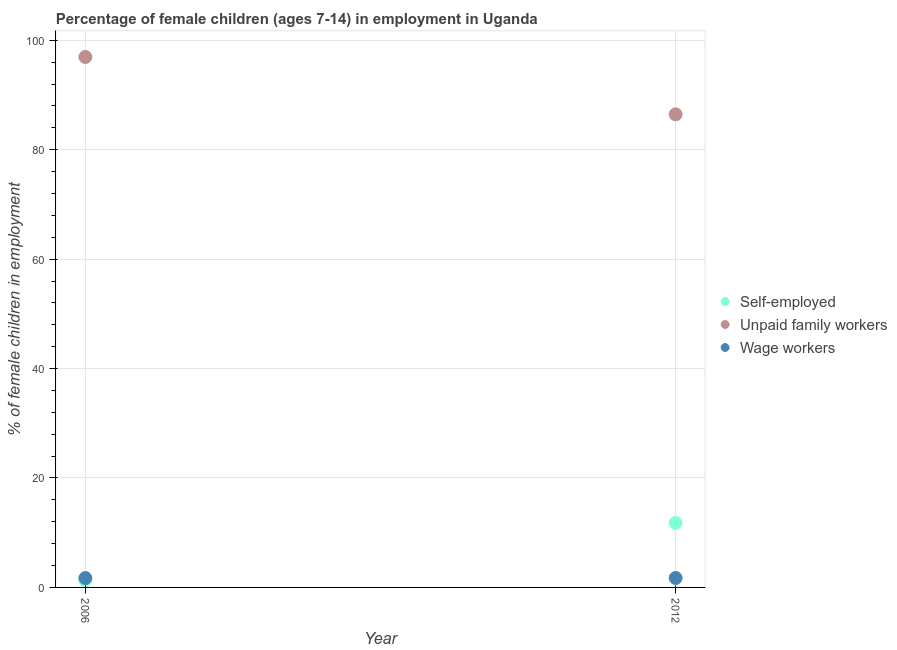What is the percentage of self employed children in 2006?
Give a very brief answer. 1.34. Across all years, what is the maximum percentage of children employed as unpaid family workers?
Offer a very short reply. 96.95. Across all years, what is the minimum percentage of children employed as unpaid family workers?
Provide a succinct answer. 86.47. In which year was the percentage of children employed as wage workers maximum?
Your answer should be very brief. 2012. What is the total percentage of children employed as unpaid family workers in the graph?
Make the answer very short. 183.42. What is the difference between the percentage of children employed as wage workers in 2006 and that in 2012?
Offer a terse response. -0.01. What is the difference between the percentage of self employed children in 2006 and the percentage of children employed as unpaid family workers in 2012?
Offer a terse response. -85.13. What is the average percentage of children employed as wage workers per year?
Ensure brevity in your answer.  1.71. In the year 2006, what is the difference between the percentage of children employed as unpaid family workers and percentage of self employed children?
Offer a terse response. 95.61. What is the ratio of the percentage of children employed as wage workers in 2006 to that in 2012?
Provide a succinct answer. 0.99. Is the percentage of self employed children in 2006 less than that in 2012?
Provide a succinct answer. Yes. Does the percentage of self employed children monotonically increase over the years?
Ensure brevity in your answer.  Yes. How many dotlines are there?
Ensure brevity in your answer.  3. How many years are there in the graph?
Your response must be concise. 2. What is the difference between two consecutive major ticks on the Y-axis?
Keep it short and to the point. 20. Does the graph contain grids?
Your response must be concise. Yes. Where does the legend appear in the graph?
Give a very brief answer. Center right. What is the title of the graph?
Make the answer very short. Percentage of female children (ages 7-14) in employment in Uganda. What is the label or title of the Y-axis?
Offer a terse response. % of female children in employment. What is the % of female children in employment in Self-employed in 2006?
Provide a short and direct response. 1.34. What is the % of female children in employment of Unpaid family workers in 2006?
Your response must be concise. 96.95. What is the % of female children in employment in Wage workers in 2006?
Give a very brief answer. 1.71. What is the % of female children in employment of Self-employed in 2012?
Provide a short and direct response. 11.79. What is the % of female children in employment of Unpaid family workers in 2012?
Your response must be concise. 86.47. What is the % of female children in employment in Wage workers in 2012?
Your response must be concise. 1.72. Across all years, what is the maximum % of female children in employment of Self-employed?
Make the answer very short. 11.79. Across all years, what is the maximum % of female children in employment in Unpaid family workers?
Offer a terse response. 96.95. Across all years, what is the maximum % of female children in employment of Wage workers?
Offer a terse response. 1.72. Across all years, what is the minimum % of female children in employment in Self-employed?
Provide a succinct answer. 1.34. Across all years, what is the minimum % of female children in employment in Unpaid family workers?
Give a very brief answer. 86.47. Across all years, what is the minimum % of female children in employment in Wage workers?
Offer a terse response. 1.71. What is the total % of female children in employment in Self-employed in the graph?
Offer a very short reply. 13.13. What is the total % of female children in employment in Unpaid family workers in the graph?
Make the answer very short. 183.42. What is the total % of female children in employment in Wage workers in the graph?
Make the answer very short. 3.43. What is the difference between the % of female children in employment of Self-employed in 2006 and that in 2012?
Offer a very short reply. -10.45. What is the difference between the % of female children in employment in Unpaid family workers in 2006 and that in 2012?
Ensure brevity in your answer.  10.48. What is the difference between the % of female children in employment in Wage workers in 2006 and that in 2012?
Provide a succinct answer. -0.01. What is the difference between the % of female children in employment of Self-employed in 2006 and the % of female children in employment of Unpaid family workers in 2012?
Make the answer very short. -85.13. What is the difference between the % of female children in employment in Self-employed in 2006 and the % of female children in employment in Wage workers in 2012?
Your answer should be very brief. -0.38. What is the difference between the % of female children in employment of Unpaid family workers in 2006 and the % of female children in employment of Wage workers in 2012?
Your response must be concise. 95.23. What is the average % of female children in employment of Self-employed per year?
Provide a short and direct response. 6.57. What is the average % of female children in employment of Unpaid family workers per year?
Your response must be concise. 91.71. What is the average % of female children in employment in Wage workers per year?
Your answer should be very brief. 1.72. In the year 2006, what is the difference between the % of female children in employment in Self-employed and % of female children in employment in Unpaid family workers?
Your answer should be very brief. -95.61. In the year 2006, what is the difference between the % of female children in employment of Self-employed and % of female children in employment of Wage workers?
Your answer should be compact. -0.37. In the year 2006, what is the difference between the % of female children in employment of Unpaid family workers and % of female children in employment of Wage workers?
Provide a succinct answer. 95.24. In the year 2012, what is the difference between the % of female children in employment in Self-employed and % of female children in employment in Unpaid family workers?
Make the answer very short. -74.68. In the year 2012, what is the difference between the % of female children in employment in Self-employed and % of female children in employment in Wage workers?
Provide a short and direct response. 10.07. In the year 2012, what is the difference between the % of female children in employment in Unpaid family workers and % of female children in employment in Wage workers?
Offer a very short reply. 84.75. What is the ratio of the % of female children in employment of Self-employed in 2006 to that in 2012?
Make the answer very short. 0.11. What is the ratio of the % of female children in employment of Unpaid family workers in 2006 to that in 2012?
Your response must be concise. 1.12. What is the difference between the highest and the second highest % of female children in employment in Self-employed?
Your response must be concise. 10.45. What is the difference between the highest and the second highest % of female children in employment in Unpaid family workers?
Your answer should be very brief. 10.48. What is the difference between the highest and the second highest % of female children in employment of Wage workers?
Your response must be concise. 0.01. What is the difference between the highest and the lowest % of female children in employment of Self-employed?
Offer a terse response. 10.45. What is the difference between the highest and the lowest % of female children in employment in Unpaid family workers?
Give a very brief answer. 10.48. What is the difference between the highest and the lowest % of female children in employment of Wage workers?
Provide a succinct answer. 0.01. 